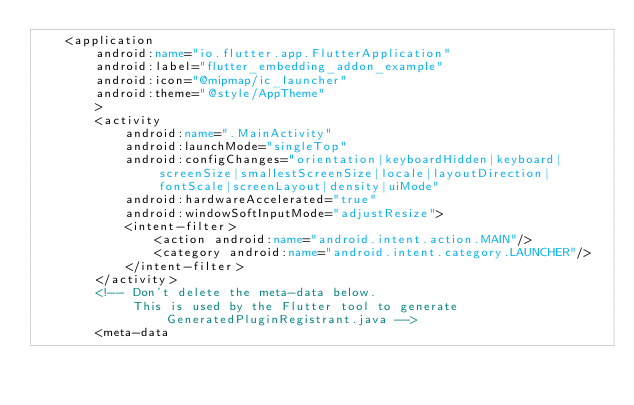<code> <loc_0><loc_0><loc_500><loc_500><_XML_>    <application
        android:name="io.flutter.app.FlutterApplication"
        android:label="flutter_embedding_addon_example"
        android:icon="@mipmap/ic_launcher"
        android:theme="@style/AppTheme"
        >
        <activity
            android:name=".MainActivity"
            android:launchMode="singleTop"
            android:configChanges="orientation|keyboardHidden|keyboard|screenSize|smallestScreenSize|locale|layoutDirection|fontScale|screenLayout|density|uiMode"
            android:hardwareAccelerated="true"
            android:windowSoftInputMode="adjustResize">
            <intent-filter>
                <action android:name="android.intent.action.MAIN"/>
                <category android:name="android.intent.category.LAUNCHER"/>
            </intent-filter>
        </activity>
        <!-- Don't delete the meta-data below.
             This is used by the Flutter tool to generate GeneratedPluginRegistrant.java -->
        <meta-data</code> 